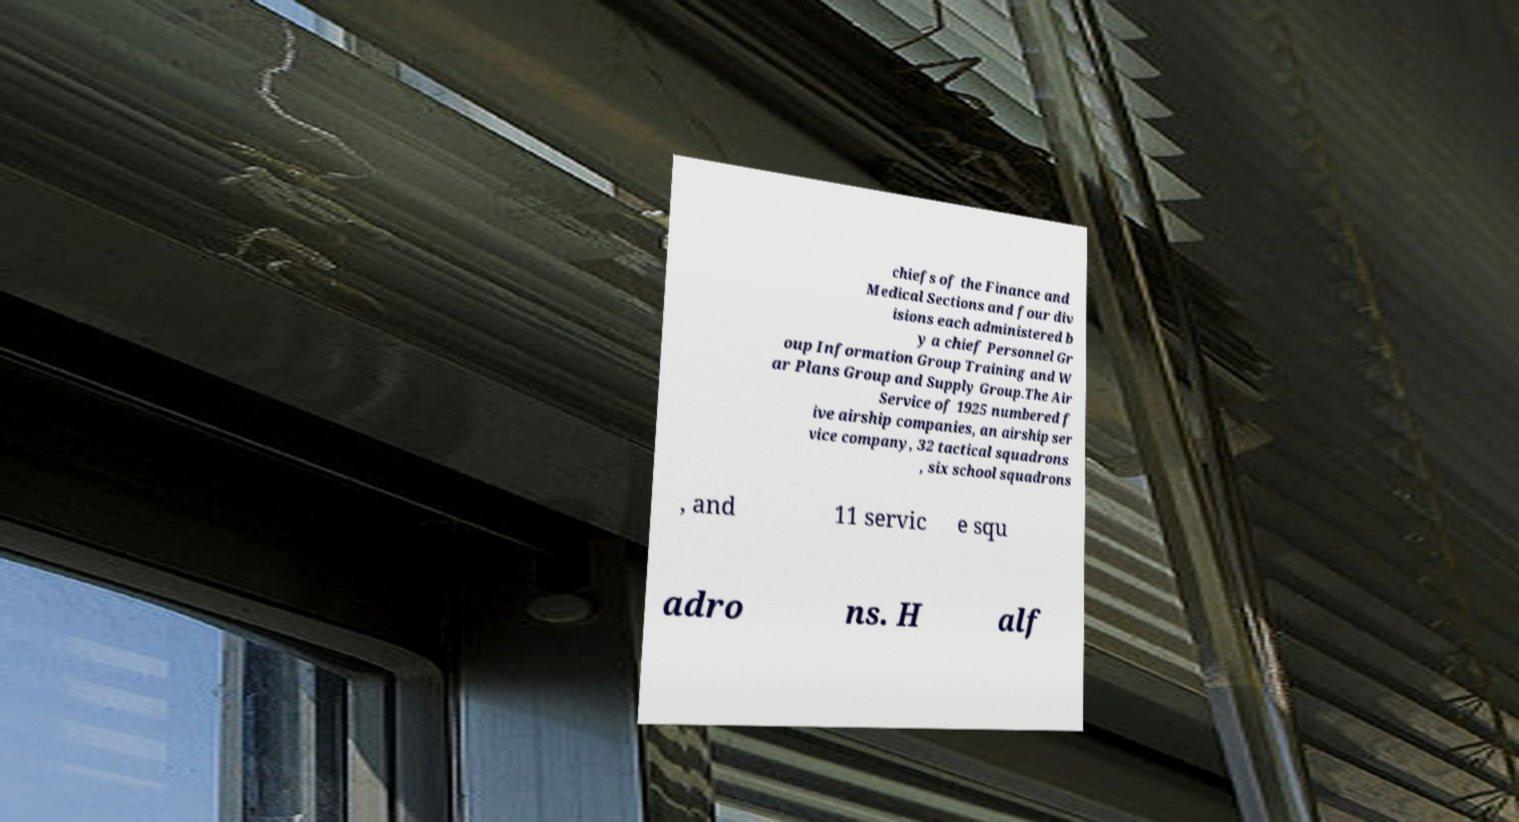Can you read and provide the text displayed in the image?This photo seems to have some interesting text. Can you extract and type it out for me? chiefs of the Finance and Medical Sections and four div isions each administered b y a chief Personnel Gr oup Information Group Training and W ar Plans Group and Supply Group.The Air Service of 1925 numbered f ive airship companies, an airship ser vice company, 32 tactical squadrons , six school squadrons , and 11 servic e squ adro ns. H alf 